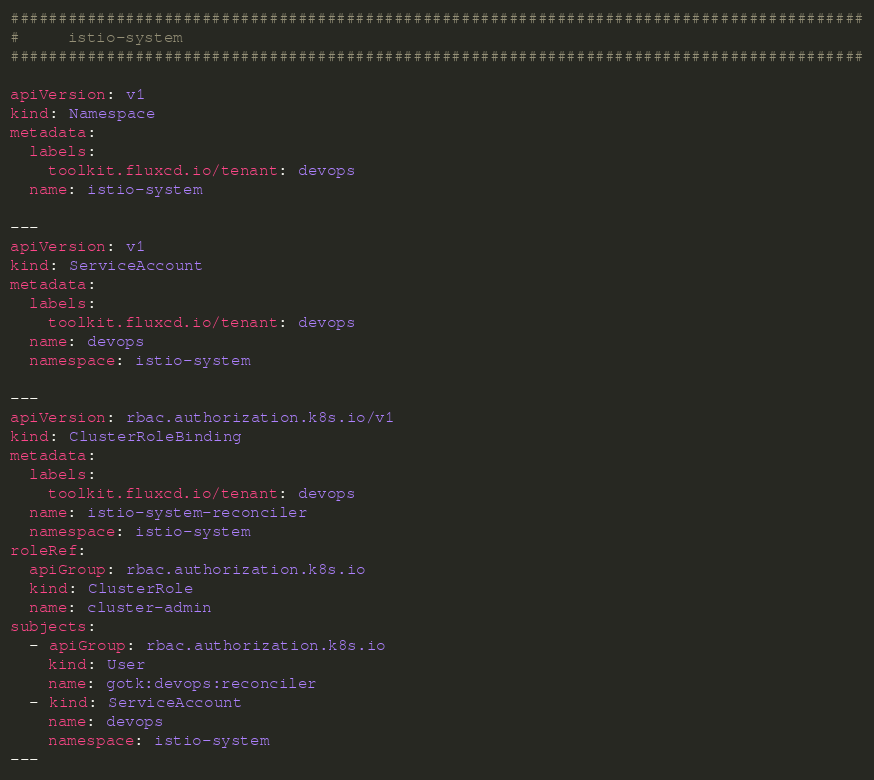<code> <loc_0><loc_0><loc_500><loc_500><_YAML_>#########################################################################################
#     istio-system
#########################################################################################

apiVersion: v1
kind: Namespace
metadata:
  labels:
    toolkit.fluxcd.io/tenant: devops
  name: istio-system

---
apiVersion: v1
kind: ServiceAccount
metadata:
  labels:
    toolkit.fluxcd.io/tenant: devops
  name: devops
  namespace: istio-system

---
apiVersion: rbac.authorization.k8s.io/v1
kind: ClusterRoleBinding
metadata:
  labels:
    toolkit.fluxcd.io/tenant: devops
  name: istio-system-reconciler
  namespace: istio-system
roleRef:
  apiGroup: rbac.authorization.k8s.io
  kind: ClusterRole
  name: cluster-admin
subjects:
  - apiGroup: rbac.authorization.k8s.io
    kind: User
    name: gotk:devops:reconciler
  - kind: ServiceAccount
    name: devops
    namespace: istio-system
---</code> 